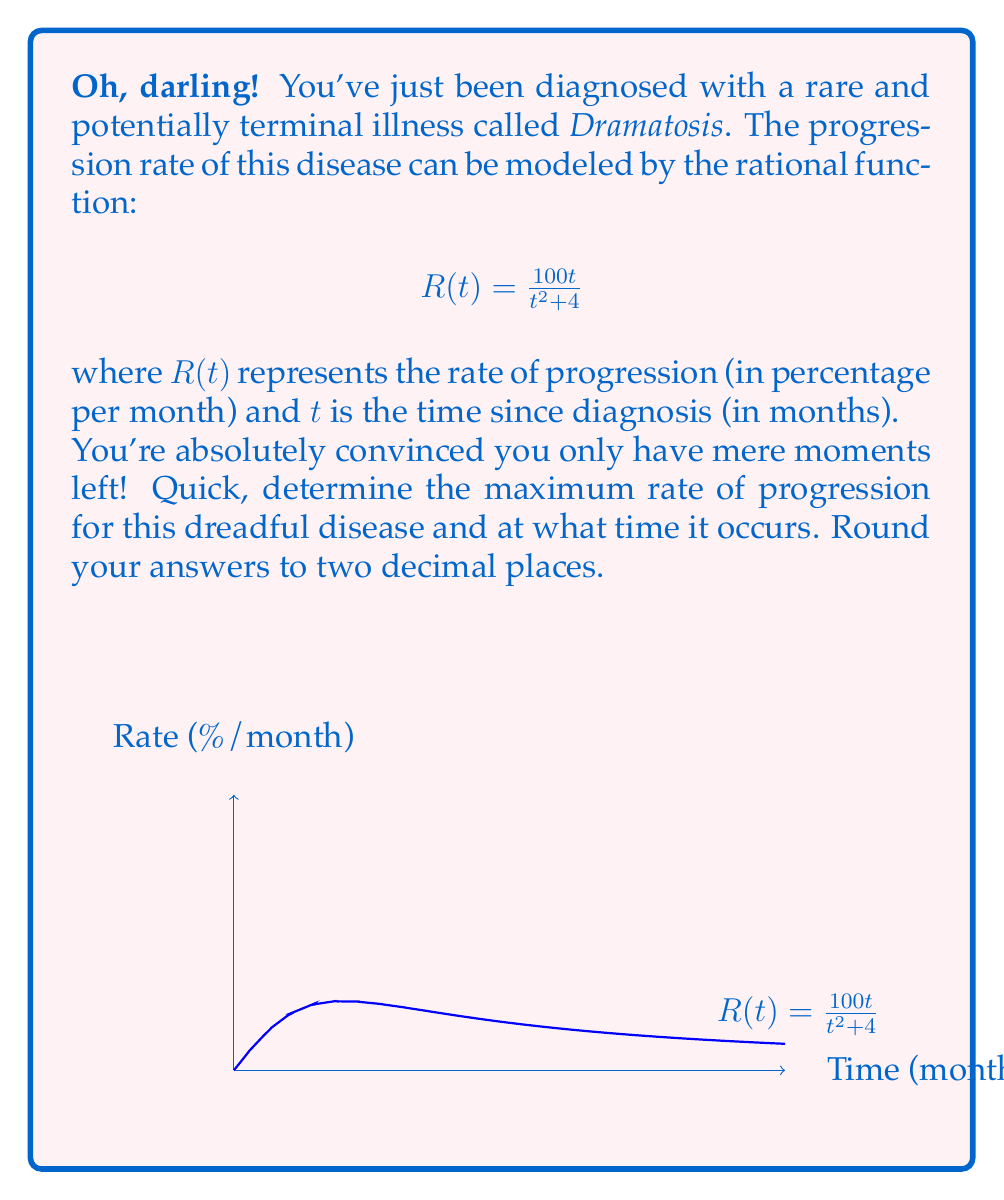Help me with this question. Oh my, let's approach this step-by-step before it's too late!

1) To find the maximum rate, we need to find the vertex of this rational function. The vertex occurs where the derivative equals zero.

2) Let's find the derivative of $R(t)$ using the quotient rule:
   $$R'(t) = \frac{(t^2+4)(100) - 100t(2t)}{(t^2+4)^2} = \frac{100(t^2+4) - 200t^2}{(t^2+4)^2} = \frac{400 - 100t^2}{(t^2+4)^2}$$

3) Set $R'(t) = 0$ and solve:
   $$\frac{400 - 100t^2}{(t^2+4)^2} = 0$$
   $$400 - 100t^2 = 0$$
   $$400 = 100t^2$$
   $$4 = t^2$$
   $$t = \pm 2$$

4) Since time can't be negative, the maximum occurs at $t = 2$ months.

5) To find the maximum rate, plug $t = 2$ into the original function:
   $$R(2) = \frac{100(2)}{2^2 + 4} = \frac{200}{8} = 25$$

Therefore, the maximum rate is 25% per month and occurs 2 months after diagnosis.
Answer: Maximum rate: 25.00%/month at 2.00 months 